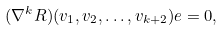<formula> <loc_0><loc_0><loc_500><loc_500>( \nabla ^ { k } R ) ( v _ { 1 } , v _ { 2 } , \dots , v _ { k + 2 } ) e = 0 ,</formula> 